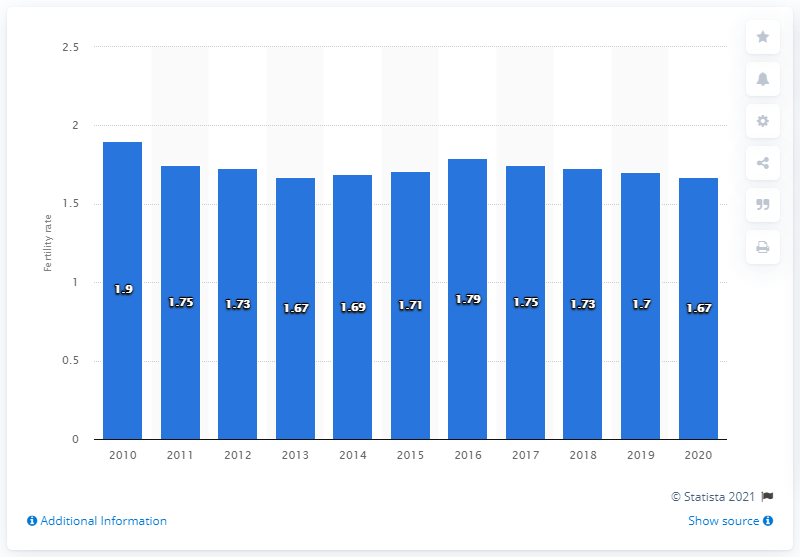Point out several critical features in this image. The fertility rate in Denmark in 2020 was 1.67 children per woman. 